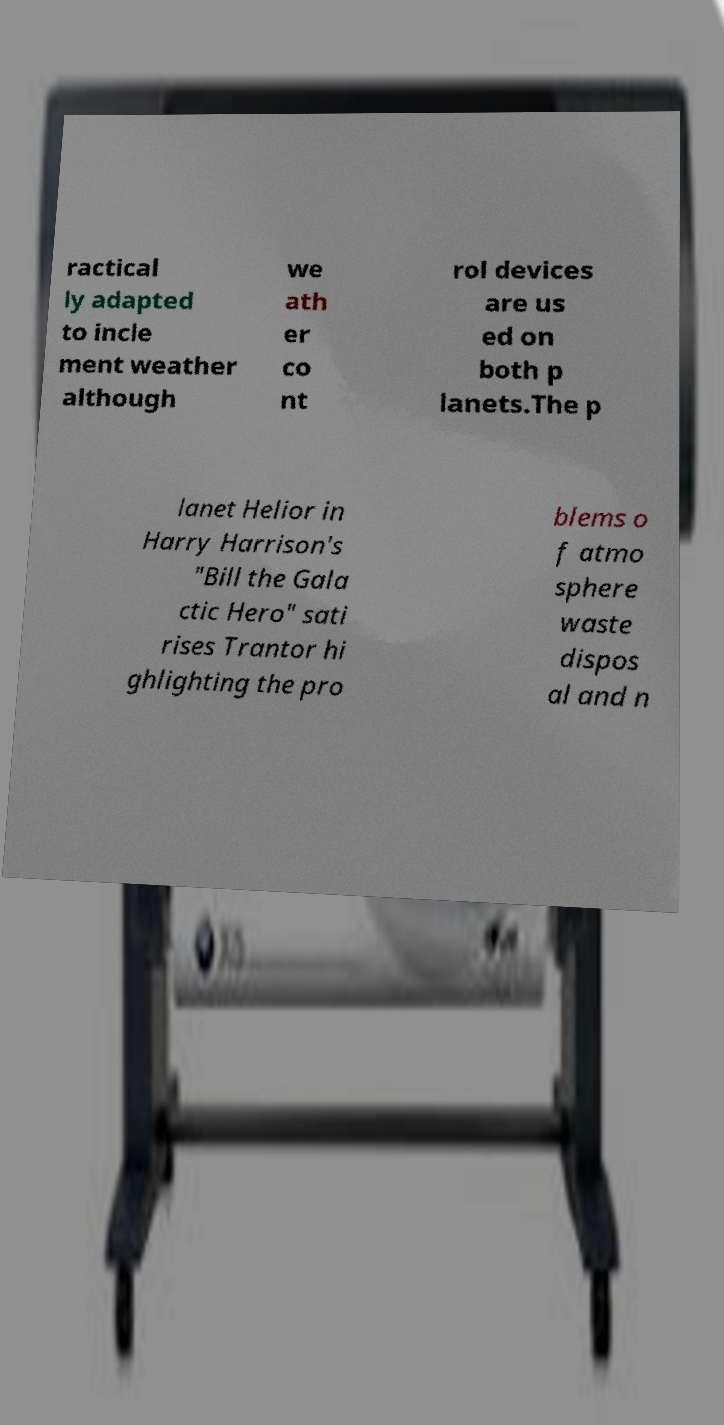What messages or text are displayed in this image? I need them in a readable, typed format. ractical ly adapted to incle ment weather although we ath er co nt rol devices are us ed on both p lanets.The p lanet Helior in Harry Harrison's "Bill the Gala ctic Hero" sati rises Trantor hi ghlighting the pro blems o f atmo sphere waste dispos al and n 